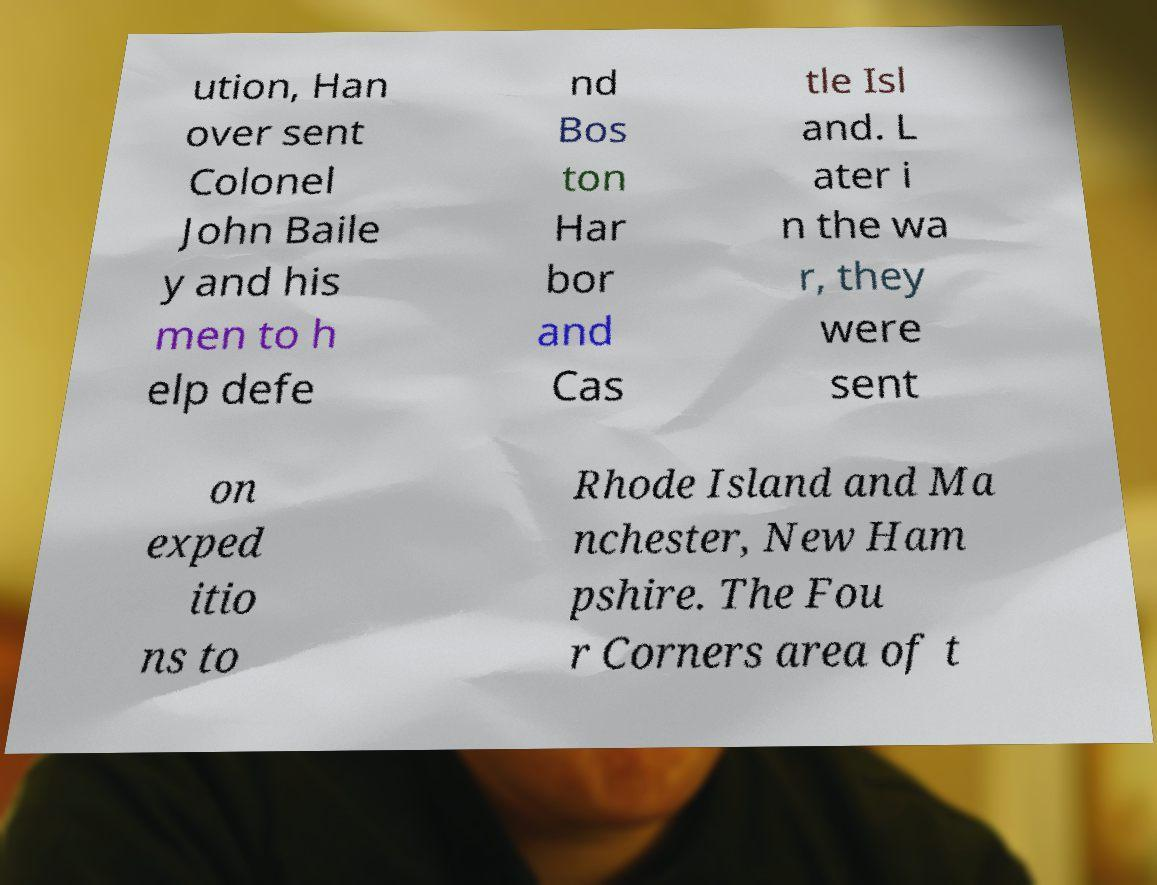Please read and relay the text visible in this image. What does it say? ution, Han over sent Colonel John Baile y and his men to h elp defe nd Bos ton Har bor and Cas tle Isl and. L ater i n the wa r, they were sent on exped itio ns to Rhode Island and Ma nchester, New Ham pshire. The Fou r Corners area of t 